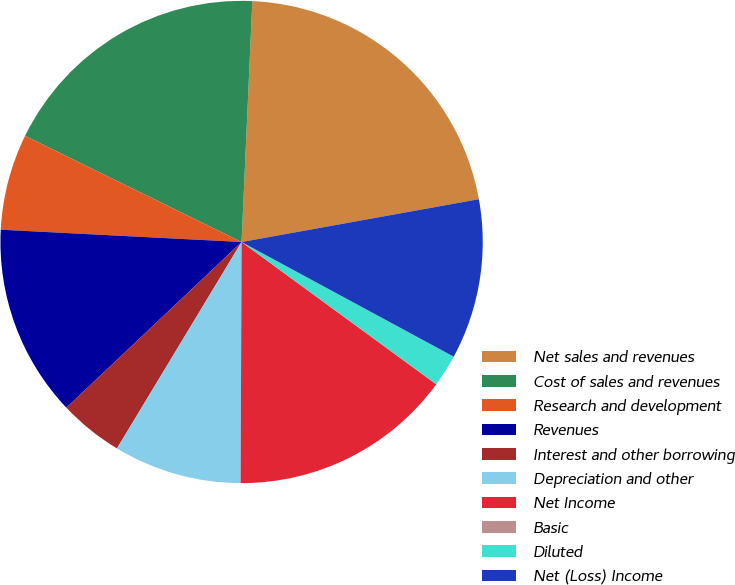Convert chart. <chart><loc_0><loc_0><loc_500><loc_500><pie_chart><fcel>Net sales and revenues<fcel>Cost of sales and revenues<fcel>Research and development<fcel>Revenues<fcel>Interest and other borrowing<fcel>Depreciation and other<fcel>Net Income<fcel>Basic<fcel>Diluted<fcel>Net (Loss) Income<nl><fcel>21.45%<fcel>18.46%<fcel>6.44%<fcel>12.87%<fcel>4.3%<fcel>8.58%<fcel>15.02%<fcel>0.01%<fcel>2.15%<fcel>10.73%<nl></chart> 